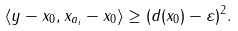Convert formula to latex. <formula><loc_0><loc_0><loc_500><loc_500>\langle y - x _ { 0 } , x _ { a _ { i } } - x _ { 0 } \rangle \geq ( d ( x _ { 0 } ) - \varepsilon ) ^ { 2 } .</formula> 